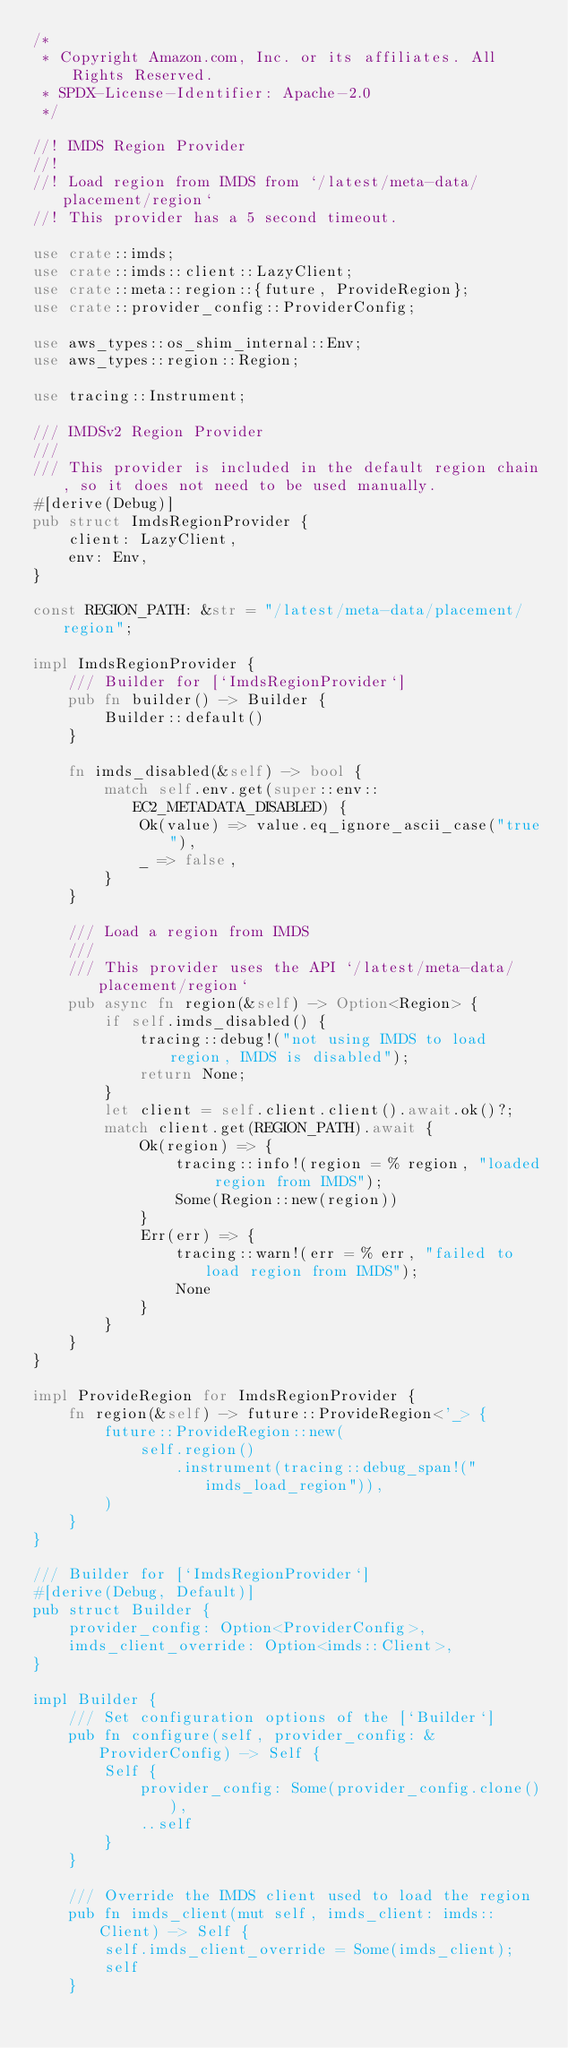<code> <loc_0><loc_0><loc_500><loc_500><_Rust_>/*
 * Copyright Amazon.com, Inc. or its affiliates. All Rights Reserved.
 * SPDX-License-Identifier: Apache-2.0
 */

//! IMDS Region Provider
//!
//! Load region from IMDS from `/latest/meta-data/placement/region`
//! This provider has a 5 second timeout.

use crate::imds;
use crate::imds::client::LazyClient;
use crate::meta::region::{future, ProvideRegion};
use crate::provider_config::ProviderConfig;

use aws_types::os_shim_internal::Env;
use aws_types::region::Region;

use tracing::Instrument;

/// IMDSv2 Region Provider
///
/// This provider is included in the default region chain, so it does not need to be used manually.
#[derive(Debug)]
pub struct ImdsRegionProvider {
    client: LazyClient,
    env: Env,
}

const REGION_PATH: &str = "/latest/meta-data/placement/region";

impl ImdsRegionProvider {
    /// Builder for [`ImdsRegionProvider`]
    pub fn builder() -> Builder {
        Builder::default()
    }

    fn imds_disabled(&self) -> bool {
        match self.env.get(super::env::EC2_METADATA_DISABLED) {
            Ok(value) => value.eq_ignore_ascii_case("true"),
            _ => false,
        }
    }

    /// Load a region from IMDS
    ///
    /// This provider uses the API `/latest/meta-data/placement/region`
    pub async fn region(&self) -> Option<Region> {
        if self.imds_disabled() {
            tracing::debug!("not using IMDS to load region, IMDS is disabled");
            return None;
        }
        let client = self.client.client().await.ok()?;
        match client.get(REGION_PATH).await {
            Ok(region) => {
                tracing::info!(region = % region, "loaded region from IMDS");
                Some(Region::new(region))
            }
            Err(err) => {
                tracing::warn!(err = % err, "failed to load region from IMDS");
                None
            }
        }
    }
}

impl ProvideRegion for ImdsRegionProvider {
    fn region(&self) -> future::ProvideRegion<'_> {
        future::ProvideRegion::new(
            self.region()
                .instrument(tracing::debug_span!("imds_load_region")),
        )
    }
}

/// Builder for [`ImdsRegionProvider`]
#[derive(Debug, Default)]
pub struct Builder {
    provider_config: Option<ProviderConfig>,
    imds_client_override: Option<imds::Client>,
}

impl Builder {
    /// Set configuration options of the [`Builder`]
    pub fn configure(self, provider_config: &ProviderConfig) -> Self {
        Self {
            provider_config: Some(provider_config.clone()),
            ..self
        }
    }

    /// Override the IMDS client used to load the region
    pub fn imds_client(mut self, imds_client: imds::Client) -> Self {
        self.imds_client_override = Some(imds_client);
        self
    }
</code> 